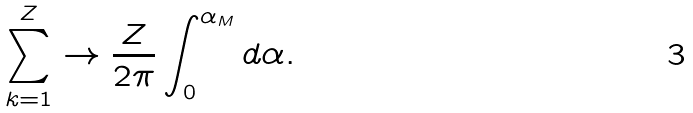Convert formula to latex. <formula><loc_0><loc_0><loc_500><loc_500>\sum _ { k = 1 } ^ { Z } \to \frac { Z } { 2 \pi } \int _ { 0 } ^ { \alpha _ { M } } d \alpha .</formula> 